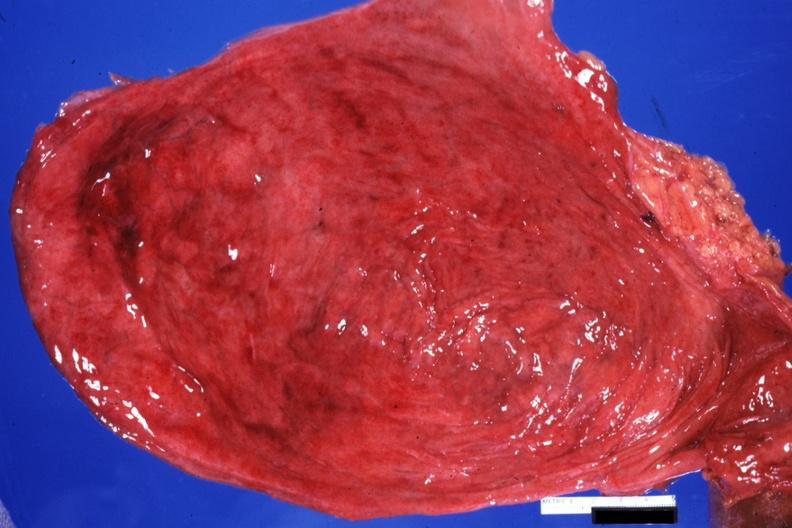what does this image show?
Answer the question using a single word or phrase. Opened bladder quite good with diverticula 